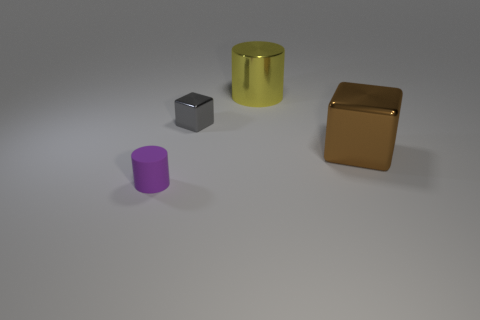What number of cylinders are both in front of the small shiny cube and behind the rubber cylinder?
Your answer should be very brief. 0. What material is the small gray block?
Make the answer very short. Metal. Are there any other things that have the same color as the tiny rubber thing?
Your answer should be compact. No. Do the tiny purple cylinder and the big yellow cylinder have the same material?
Make the answer very short. No. How many yellow metal things are to the left of the large thing left of the cube right of the small cube?
Provide a succinct answer. 0. How many metal cylinders are there?
Offer a terse response. 1. Is the number of brown metallic cubes that are left of the tiny gray metallic thing less than the number of rubber objects right of the purple rubber object?
Your response must be concise. No. Are there fewer tiny cylinders that are in front of the rubber cylinder than brown objects?
Your response must be concise. Yes. There is a tiny thing that is behind the purple object in front of the big yellow cylinder behind the brown metal thing; what is its material?
Give a very brief answer. Metal. What number of objects are small things that are in front of the brown block or tiny purple cylinders to the left of the large brown thing?
Provide a short and direct response. 1. 